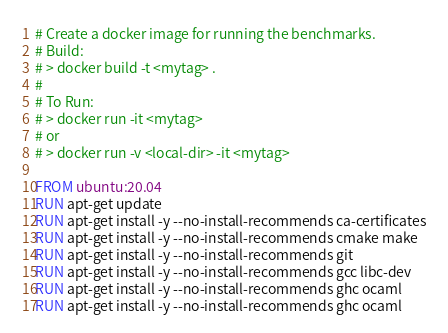<code> <loc_0><loc_0><loc_500><loc_500><_Dockerfile_># Create a docker image for running the benchmarks.
# Build:
# > docker build -t <mytag> .
#
# To Run:
# > docker run -it <mytag>
# or
# > docker run -v <local-dir> -it <mytag>

FROM ubuntu:20.04
RUN apt-get update
RUN apt-get install -y --no-install-recommends ca-certificates
RUN apt-get install -y --no-install-recommends cmake make
RUN apt-get install -y --no-install-recommends git
RUN apt-get install -y --no-install-recommends gcc libc-dev
RUN apt-get install -y --no-install-recommends ghc ocaml
RUN apt-get install -y --no-install-recommends ghc ocaml</code> 